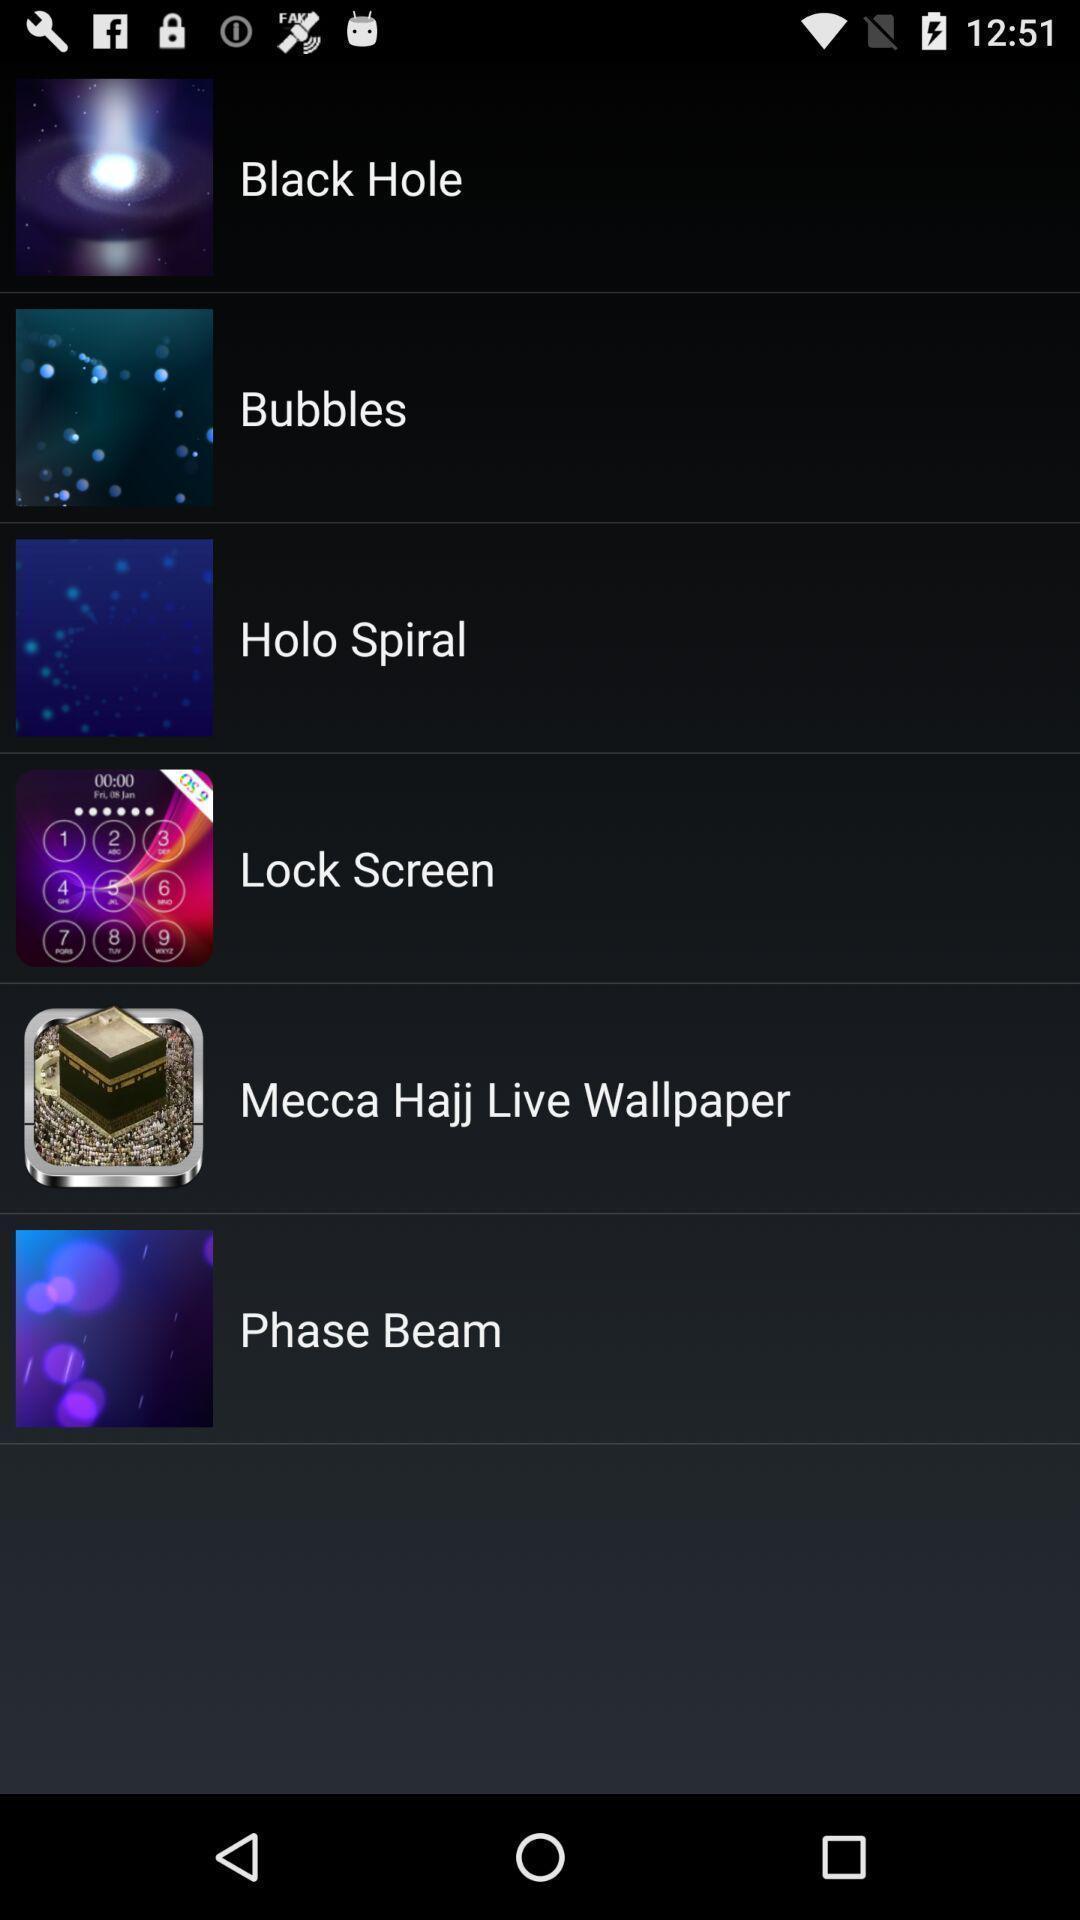Summarize the main components in this picture. Screen displaying the list of options. 